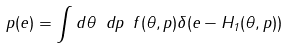Convert formula to latex. <formula><loc_0><loc_0><loc_500><loc_500>p ( e ) = \int d \theta \ d p \ f ( \theta , p ) \delta ( e - H _ { 1 } ( \theta , p ) )</formula> 